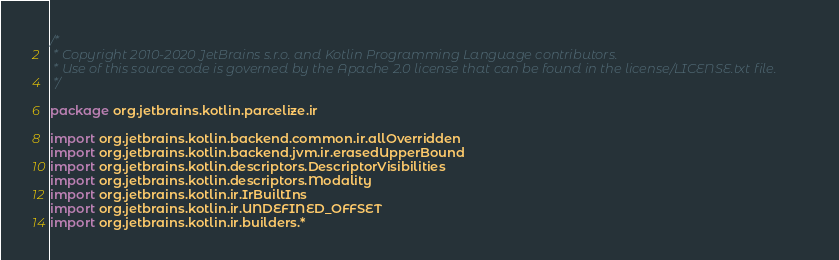Convert code to text. <code><loc_0><loc_0><loc_500><loc_500><_Kotlin_>/*
 * Copyright 2010-2020 JetBrains s.r.o. and Kotlin Programming Language contributors.
 * Use of this source code is governed by the Apache 2.0 license that can be found in the license/LICENSE.txt file.
 */

package org.jetbrains.kotlin.parcelize.ir

import org.jetbrains.kotlin.backend.common.ir.allOverridden
import org.jetbrains.kotlin.backend.jvm.ir.erasedUpperBound
import org.jetbrains.kotlin.descriptors.DescriptorVisibilities
import org.jetbrains.kotlin.descriptors.Modality
import org.jetbrains.kotlin.ir.IrBuiltIns
import org.jetbrains.kotlin.ir.UNDEFINED_OFFSET
import org.jetbrains.kotlin.ir.builders.*</code> 